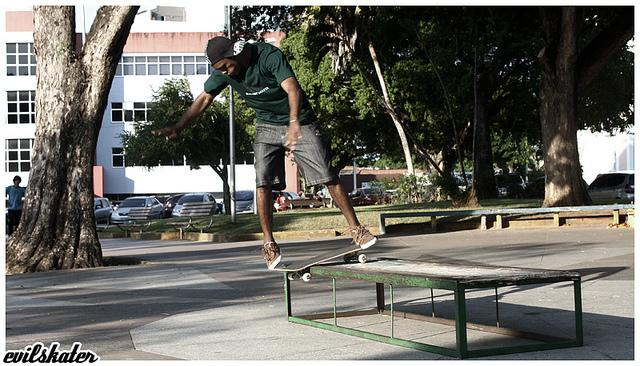What wheeled object is the man riding on to perform the stunt? Please explain your reasoning. skateboard. A guy is on a board with wheels on the bottom in the front and back and he is riding a rail as skateboarders often do. 